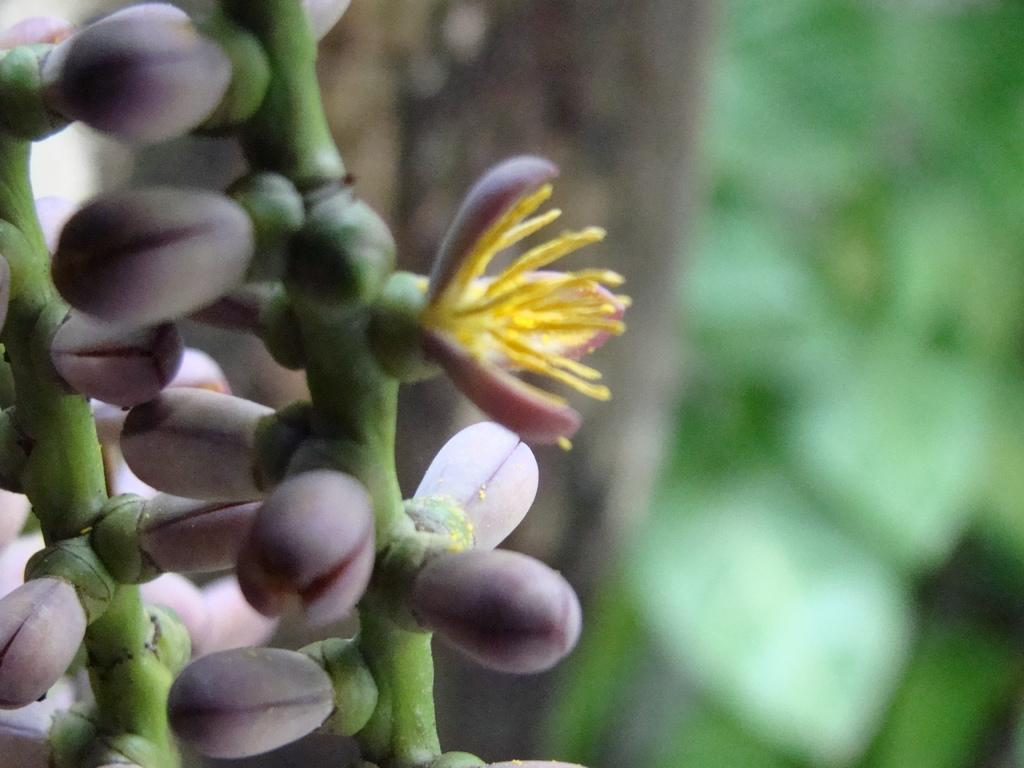What is the main subject of the image? The main subject of the image is a plant. What color are the flowers on the plant? The flowers on the plant are pink. Can you describe the background of the image? The background of the image is blurry. What type of linen is draped over the plant in the image? There is no linen present in the image; it only features a plant with pink flowers and a blurry background. 